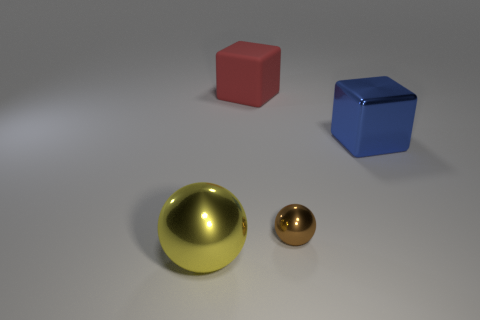What number of blue cylinders are there?
Ensure brevity in your answer.  0. Are the big sphere and the big cube to the right of the big red rubber object made of the same material?
Your answer should be compact. Yes. What number of red objects are cubes or large spheres?
Keep it short and to the point. 1. What size is the brown object that is the same material as the big blue block?
Give a very brief answer. Small. How many large green metallic things are the same shape as the large red rubber thing?
Make the answer very short. 0. Are there more shiny spheres that are in front of the brown shiny ball than big matte cubes that are in front of the big blue thing?
Your answer should be compact. Yes. There is a red thing that is the same size as the yellow ball; what material is it?
Your answer should be compact. Rubber. How many objects are either yellow balls or large metallic things to the left of the blue shiny block?
Provide a short and direct response. 1. There is a red block; is its size the same as the shiny ball that is to the right of the large metallic sphere?
Ensure brevity in your answer.  No. What number of blocks are either big red things or blue objects?
Your answer should be very brief. 2. 